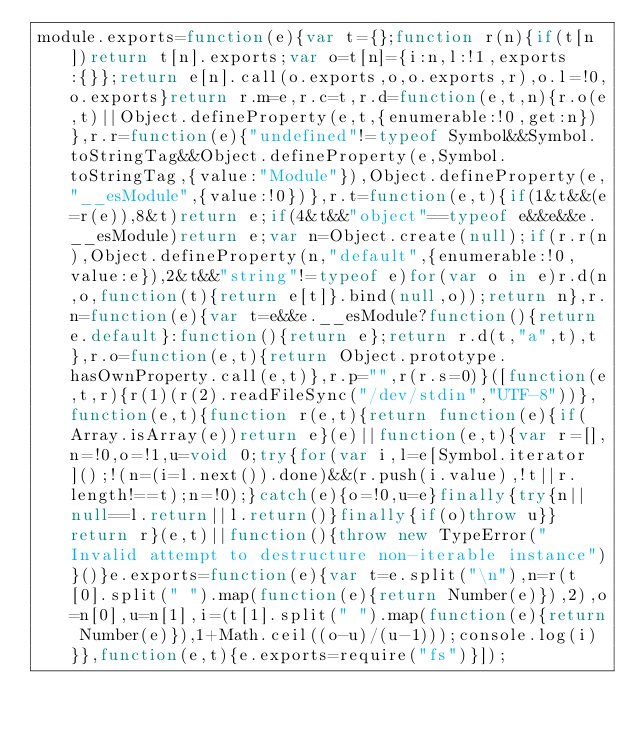Convert code to text. <code><loc_0><loc_0><loc_500><loc_500><_JavaScript_>module.exports=function(e){var t={};function r(n){if(t[n])return t[n].exports;var o=t[n]={i:n,l:!1,exports:{}};return e[n].call(o.exports,o,o.exports,r),o.l=!0,o.exports}return r.m=e,r.c=t,r.d=function(e,t,n){r.o(e,t)||Object.defineProperty(e,t,{enumerable:!0,get:n})},r.r=function(e){"undefined"!=typeof Symbol&&Symbol.toStringTag&&Object.defineProperty(e,Symbol.toStringTag,{value:"Module"}),Object.defineProperty(e,"__esModule",{value:!0})},r.t=function(e,t){if(1&t&&(e=r(e)),8&t)return e;if(4&t&&"object"==typeof e&&e&&e.__esModule)return e;var n=Object.create(null);if(r.r(n),Object.defineProperty(n,"default",{enumerable:!0,value:e}),2&t&&"string"!=typeof e)for(var o in e)r.d(n,o,function(t){return e[t]}.bind(null,o));return n},r.n=function(e){var t=e&&e.__esModule?function(){return e.default}:function(){return e};return r.d(t,"a",t),t},r.o=function(e,t){return Object.prototype.hasOwnProperty.call(e,t)},r.p="",r(r.s=0)}([function(e,t,r){r(1)(r(2).readFileSync("/dev/stdin","UTF-8"))},function(e,t){function r(e,t){return function(e){if(Array.isArray(e))return e}(e)||function(e,t){var r=[],n=!0,o=!1,u=void 0;try{for(var i,l=e[Symbol.iterator]();!(n=(i=l.next()).done)&&(r.push(i.value),!t||r.length!==t);n=!0);}catch(e){o=!0,u=e}finally{try{n||null==l.return||l.return()}finally{if(o)throw u}}return r}(e,t)||function(){throw new TypeError("Invalid attempt to destructure non-iterable instance")}()}e.exports=function(e){var t=e.split("\n"),n=r(t[0].split(" ").map(function(e){return Number(e)}),2),o=n[0],u=n[1],i=(t[1].split(" ").map(function(e){return Number(e)}),1+Math.ceil((o-u)/(u-1)));console.log(i)}},function(e,t){e.exports=require("fs")}]);</code> 